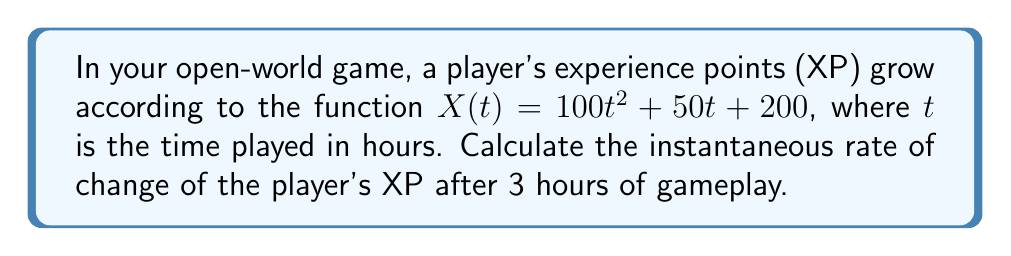Teach me how to tackle this problem. To find the instantaneous rate of change of the player's XP after 3 hours of gameplay, we need to calculate the derivative of the XP function $X(t)$ and evaluate it at $t = 3$.

1. Given XP function: $X(t) = 100t^2 + 50t + 200$

2. Find the derivative $X'(t)$:
   $$\begin{align}
   X'(t) &= \frac{d}{dt}(100t^2 + 50t + 200) \\
   &= 200t + 50
   \end{align}$$

3. Evaluate $X'(t)$ at $t = 3$:
   $$\begin{align}
   X'(3) &= 200(3) + 50 \\
   &= 600 + 50 \\
   &= 650
   \end{align}$$

The instantaneous rate of change of the player's XP after 3 hours of gameplay is 650 XP per hour.

This result means that at exactly 3 hours into the game, the player's XP is increasing at a rate of 650 points per hour. This information can be useful for game balancing and designing the player progression system.
Answer: 650 XP per hour 